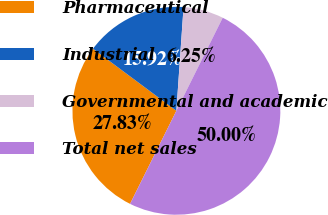Convert chart. <chart><loc_0><loc_0><loc_500><loc_500><pie_chart><fcel>Pharmaceutical<fcel>Industrial<fcel>Governmental and academic<fcel>Total net sales<nl><fcel>27.83%<fcel>15.92%<fcel>6.25%<fcel>50.0%<nl></chart> 